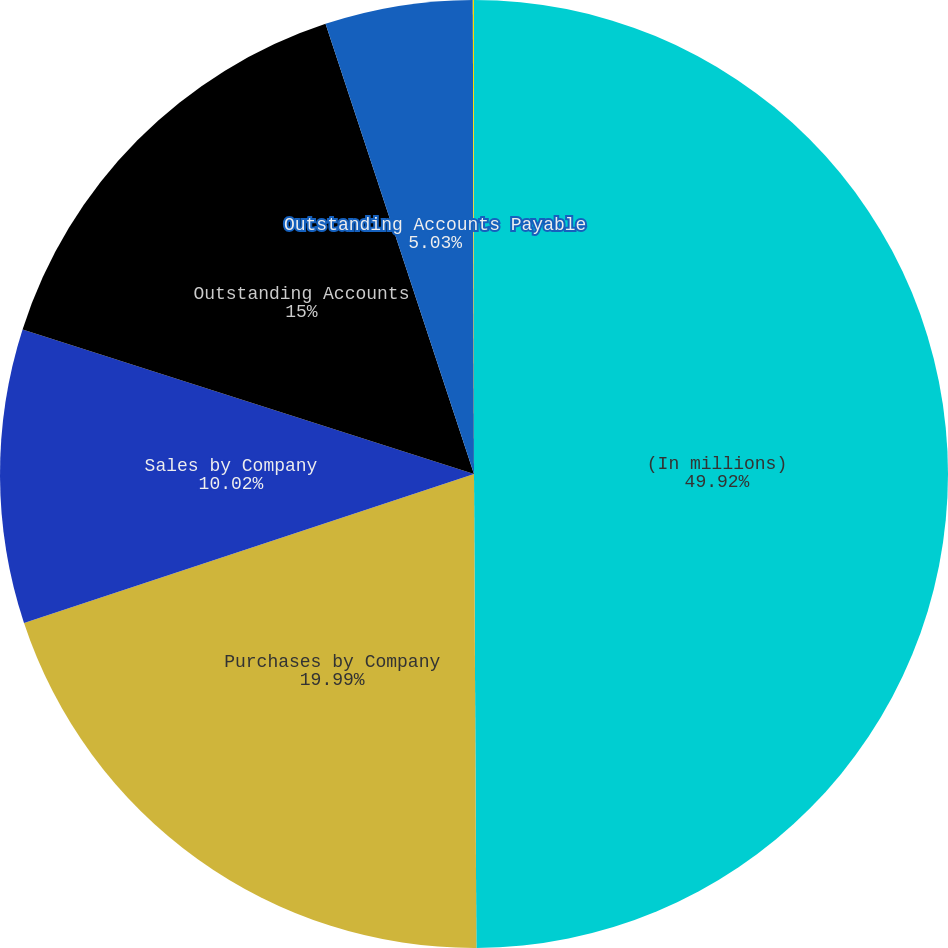<chart> <loc_0><loc_0><loc_500><loc_500><pie_chart><fcel>(In millions)<fcel>Purchases by Company<fcel>Sales by Company<fcel>Outstanding Accounts<fcel>Outstanding Accounts Payable<fcel>Administration & Management<nl><fcel>49.92%<fcel>19.99%<fcel>10.02%<fcel>15.0%<fcel>5.03%<fcel>0.04%<nl></chart> 